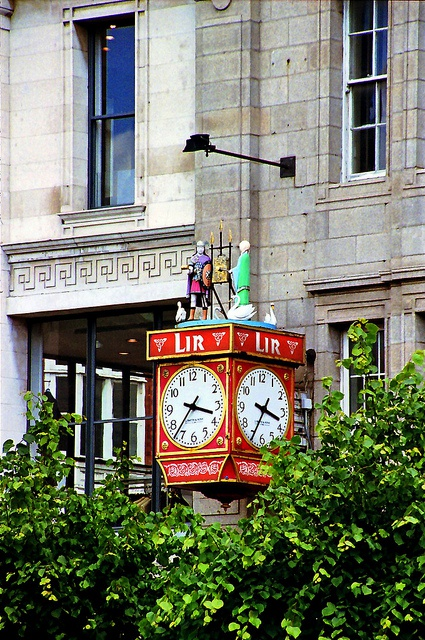Describe the objects in this image and their specific colors. I can see clock in darkgray, white, black, and khaki tones and clock in darkgray, lightgray, black, and olive tones in this image. 